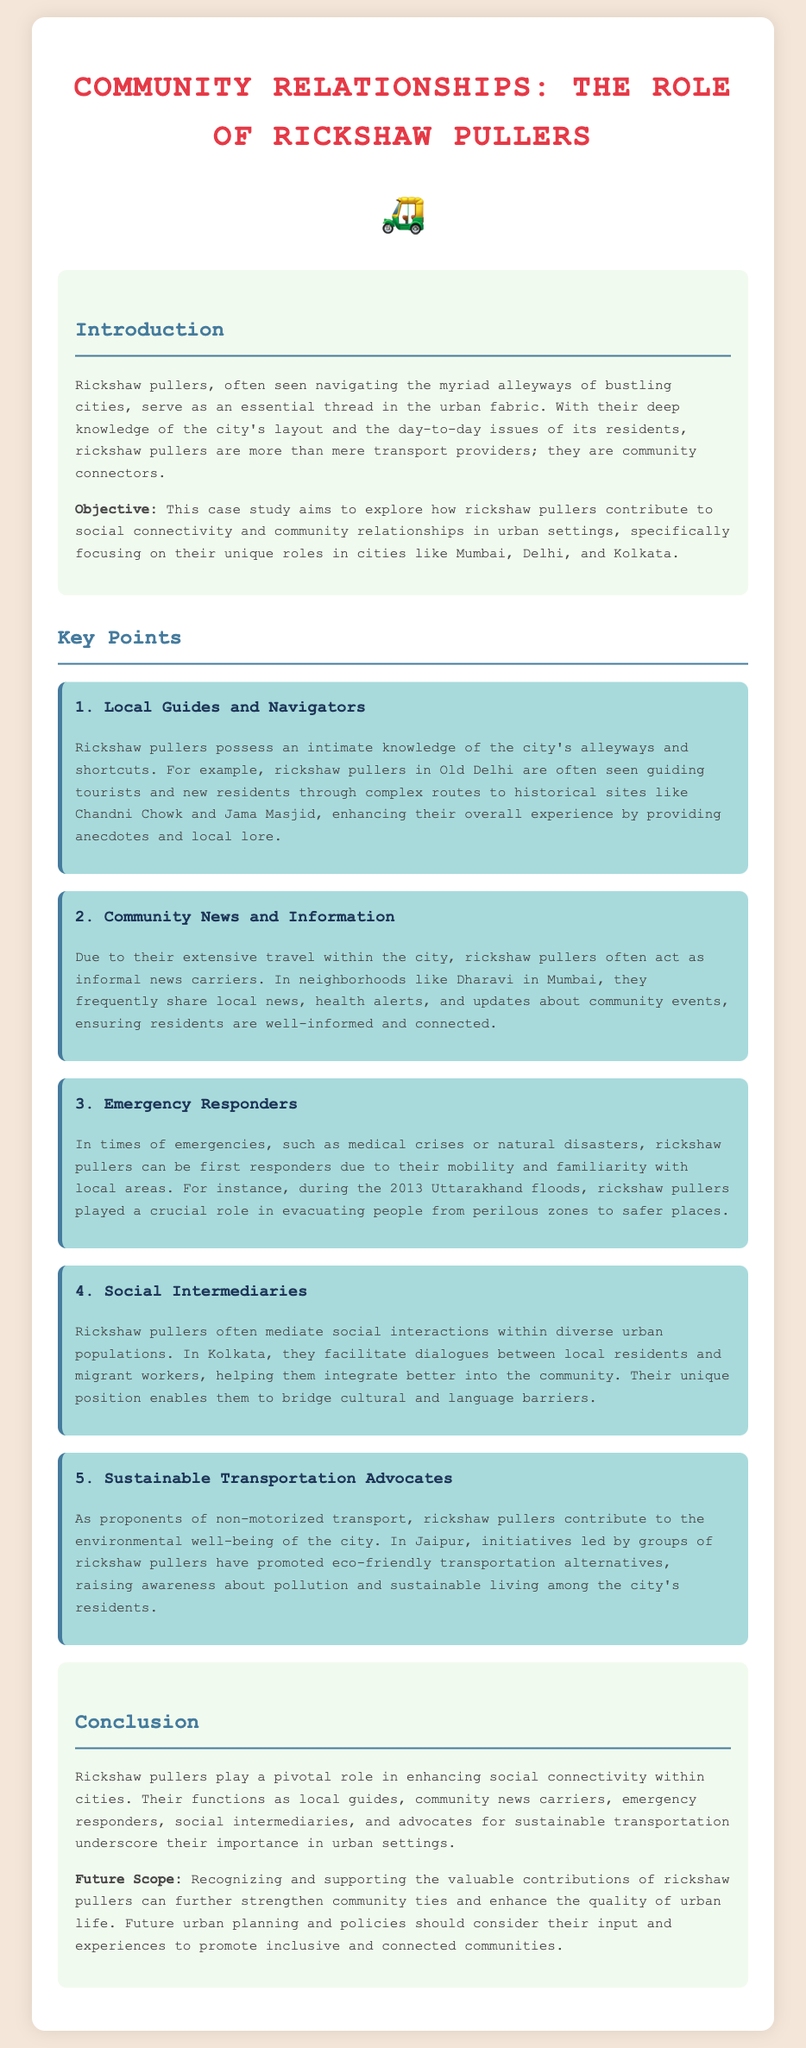What is the title of the case study? The title of the case study is clearly stated at the top of the document.
Answer: Community Relationships: The Role of Rickshaw Pullers In which city did rickshaw pullers help during the 2013 floods? The document highlights an example where rickshaw pullers were involved in emergency response during the 2013 Uttarakhand floods.
Answer: Uttarakhand What role do rickshaw pullers play in sharing local news? The document explains that rickshaw pullers act as informal news carriers due to their extensive travel.
Answer: Informal news carriers What is one example of a historical site mentioned in relation to rickshaw pullers? The document provides an example of historical sites where rickshaw pullers guide passengers in Old Delhi.
Answer: Chandni Chowk Which city is mentioned regarding sustainable transportation advocacy? The document refers to initiatives led by rickshaw pullers that promoted eco-friendly transport, specifically in one city.
Answer: Jaipur How do rickshaw pullers assist in social integration? The document mentions that rickshaw pullers facilitate dialogues between different groups.
Answer: Facilitate dialogues What is the main objective of this case study? The document states that the objective is to explore contributions of rickshaw pullers in social connectivity in urban settings.
Answer: Explore social connectivity What is a potential future scope mentioned in the conclusion? The document highlights that recognizing rickshaw pullers' contributions can strengthen community ties as a future scope.
Answer: Strengthen community ties 